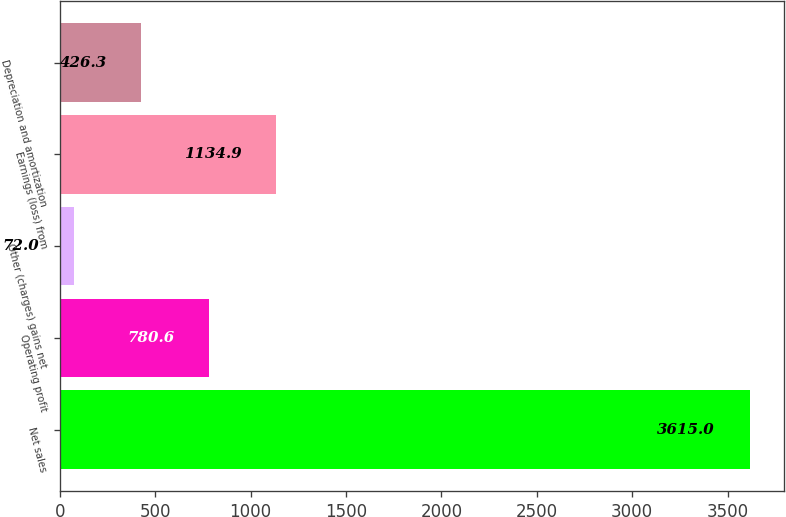Convert chart to OTSL. <chart><loc_0><loc_0><loc_500><loc_500><bar_chart><fcel>Net sales<fcel>Operating profit<fcel>Other (charges) gains net<fcel>Earnings (loss) from<fcel>Depreciation and amortization<nl><fcel>3615<fcel>780.6<fcel>72<fcel>1134.9<fcel>426.3<nl></chart> 